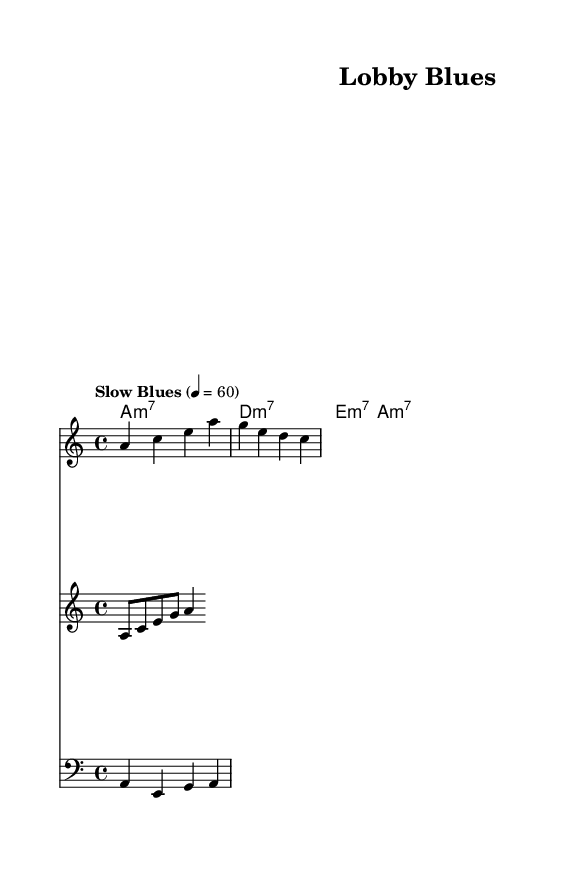What is the key signature of this music? The key signature is indicated at the beginning of the sheet and shows A minor, which has no sharps or flats.
Answer: A minor What is the time signature of the piece? The time signature is displayed at the beginning of the sheet music, showing it is in 4/4 time, meaning there are four beats per measure.
Answer: 4/4 What is the tempo marking for this piece? The tempo marking is found at the start of the score, specifying it as "Slow Blues" with a beat of 60, indicating a slow pace.
Answer: Slow Blues How many measures are included in the melody? Counting the measures in the melody line, there are a total of four measures represented.
Answer: Four What is the primary theme addressed in the lyrics? Observing the lyrics, the theme revolves around corporate influence and democratic issues, highlighting the struggle against political inequality.
Answer: Corporate influence How is the structure of the piece organized? By analyzing the score, it can be seen that the piece is structured in verses followed by a chorus, typical of Blues music, with a call-and-response format.
Answer: Verse and Chorus What type of chords are predominantly used in this piece? Looking at the chord names, it can be noted that the chords used are minor seventh chords, which are characteristic of the Blues genre, providing a rich harmonic texture.
Answer: Minor seventh chords 